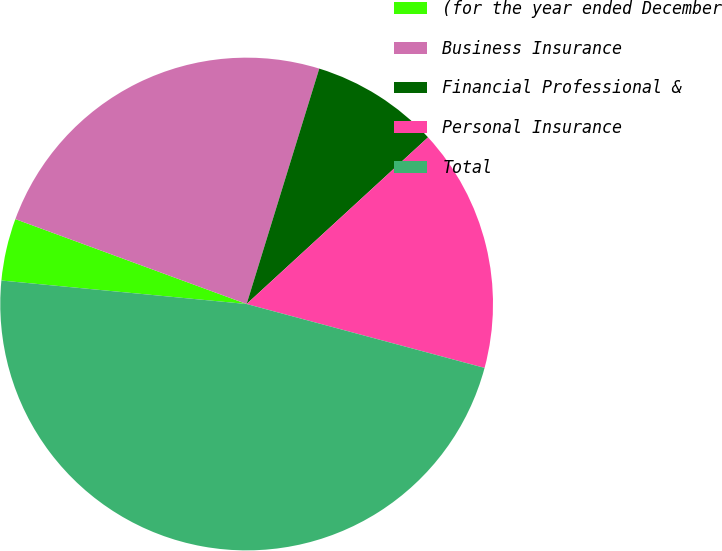Convert chart to OTSL. <chart><loc_0><loc_0><loc_500><loc_500><pie_chart><fcel>(for the year ended December<fcel>Business Insurance<fcel>Financial Professional &<fcel>Personal Insurance<fcel>Total<nl><fcel>4.08%<fcel>24.16%<fcel>8.41%<fcel>16.0%<fcel>47.34%<nl></chart> 